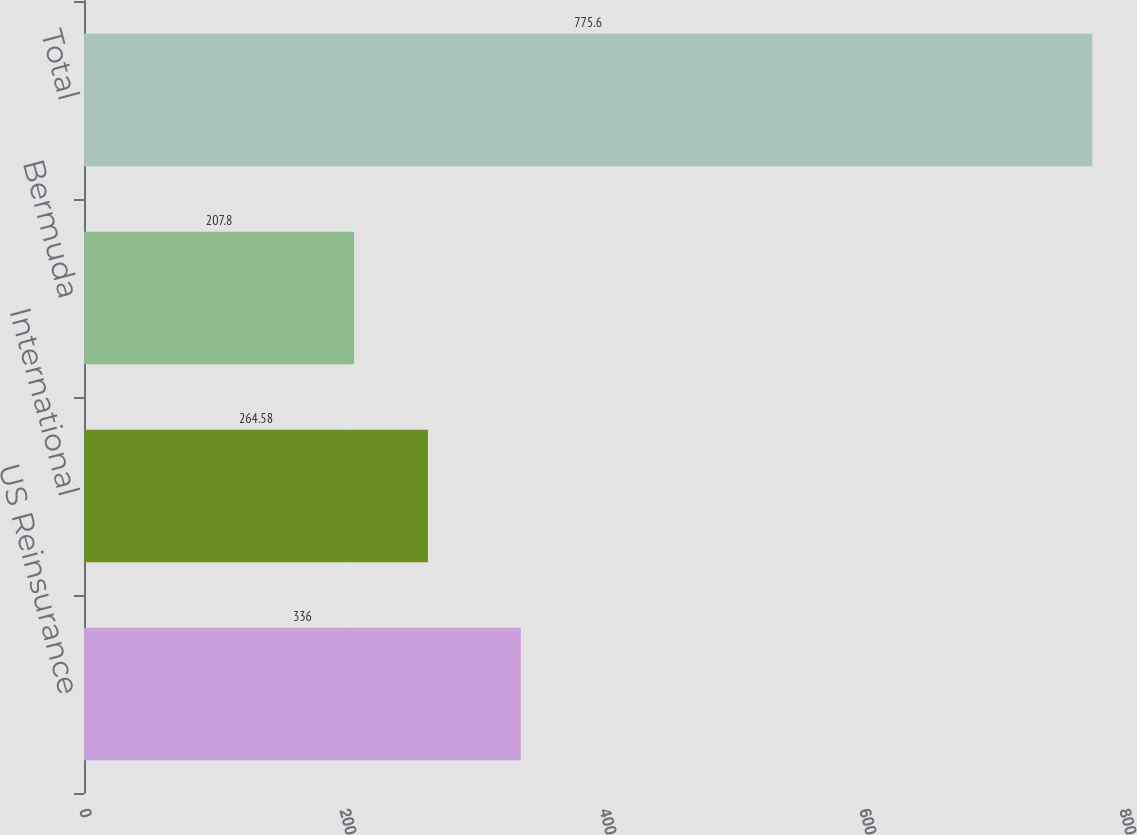Convert chart. <chart><loc_0><loc_0><loc_500><loc_500><bar_chart><fcel>US Reinsurance<fcel>International<fcel>Bermuda<fcel>Total<nl><fcel>336<fcel>264.58<fcel>207.8<fcel>775.6<nl></chart> 